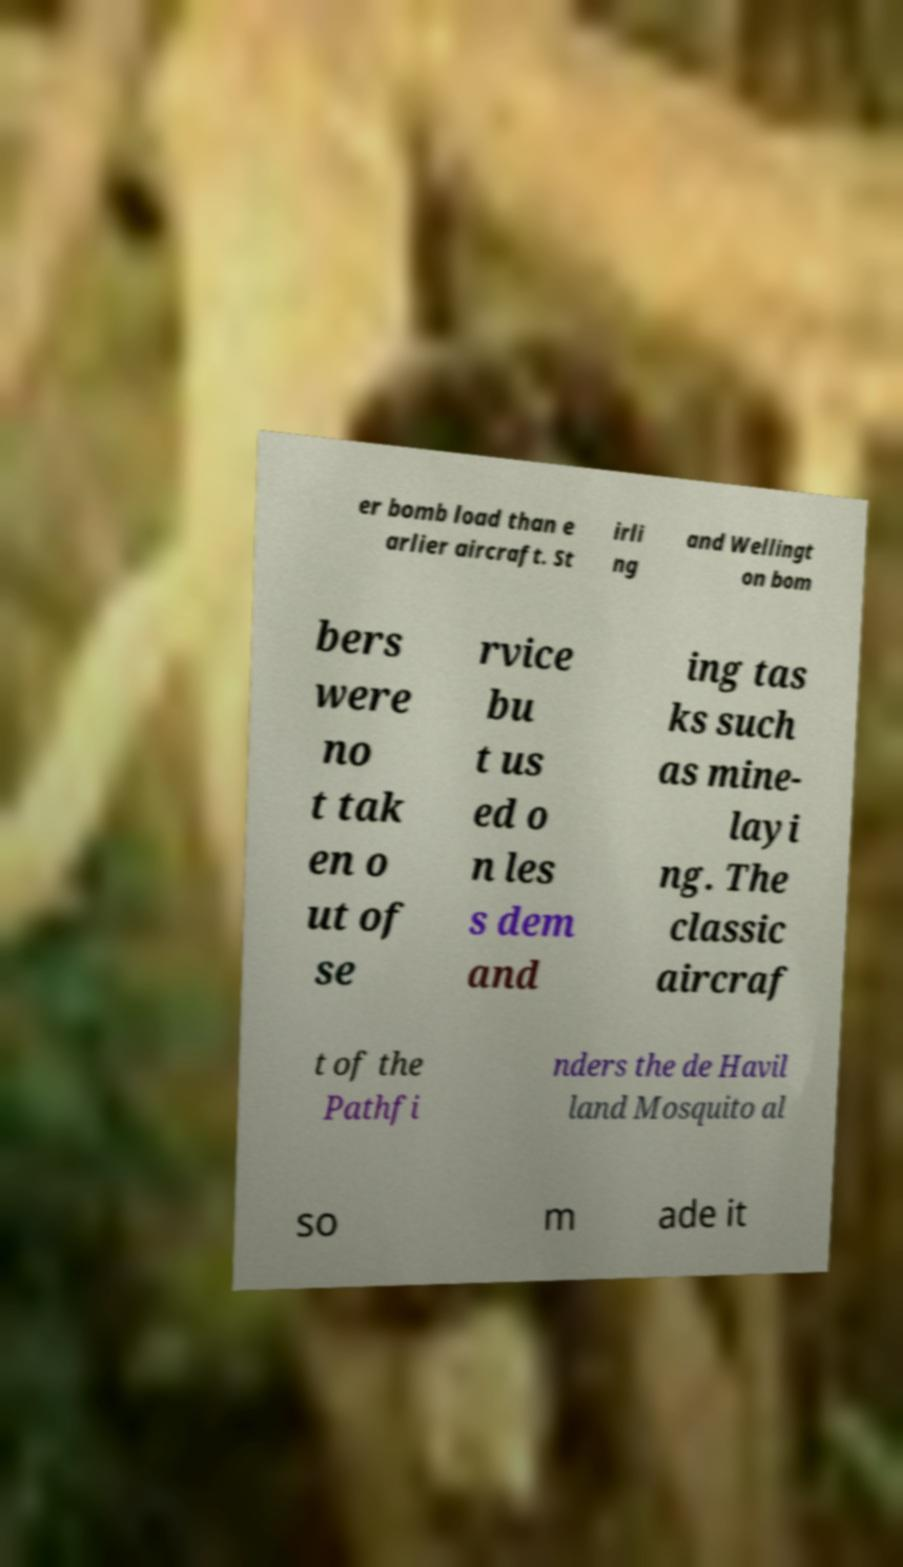There's text embedded in this image that I need extracted. Can you transcribe it verbatim? er bomb load than e arlier aircraft. St irli ng and Wellingt on bom bers were no t tak en o ut of se rvice bu t us ed o n les s dem and ing tas ks such as mine- layi ng. The classic aircraf t of the Pathfi nders the de Havil land Mosquito al so m ade it 